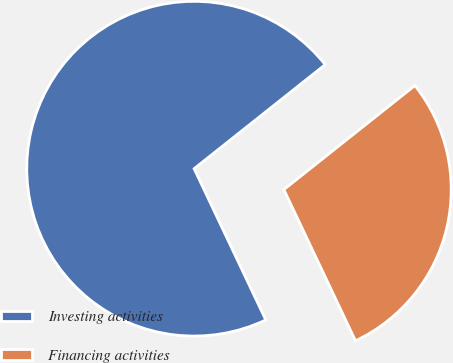Convert chart. <chart><loc_0><loc_0><loc_500><loc_500><pie_chart><fcel>Investing activities<fcel>Financing activities<nl><fcel>71.36%<fcel>28.64%<nl></chart> 